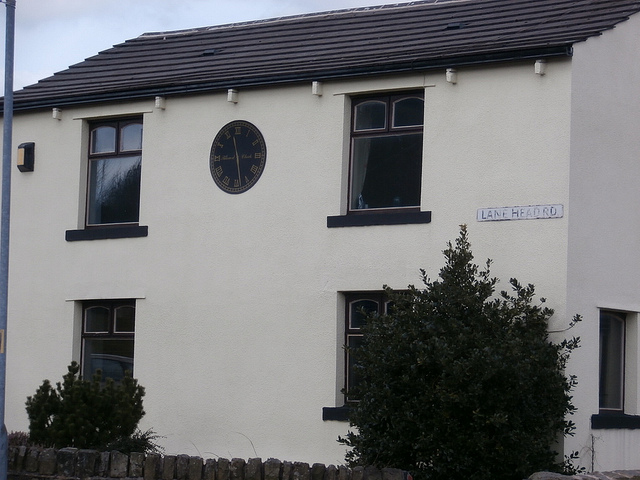Extract all visible text content from this image. LANE HEADRD 